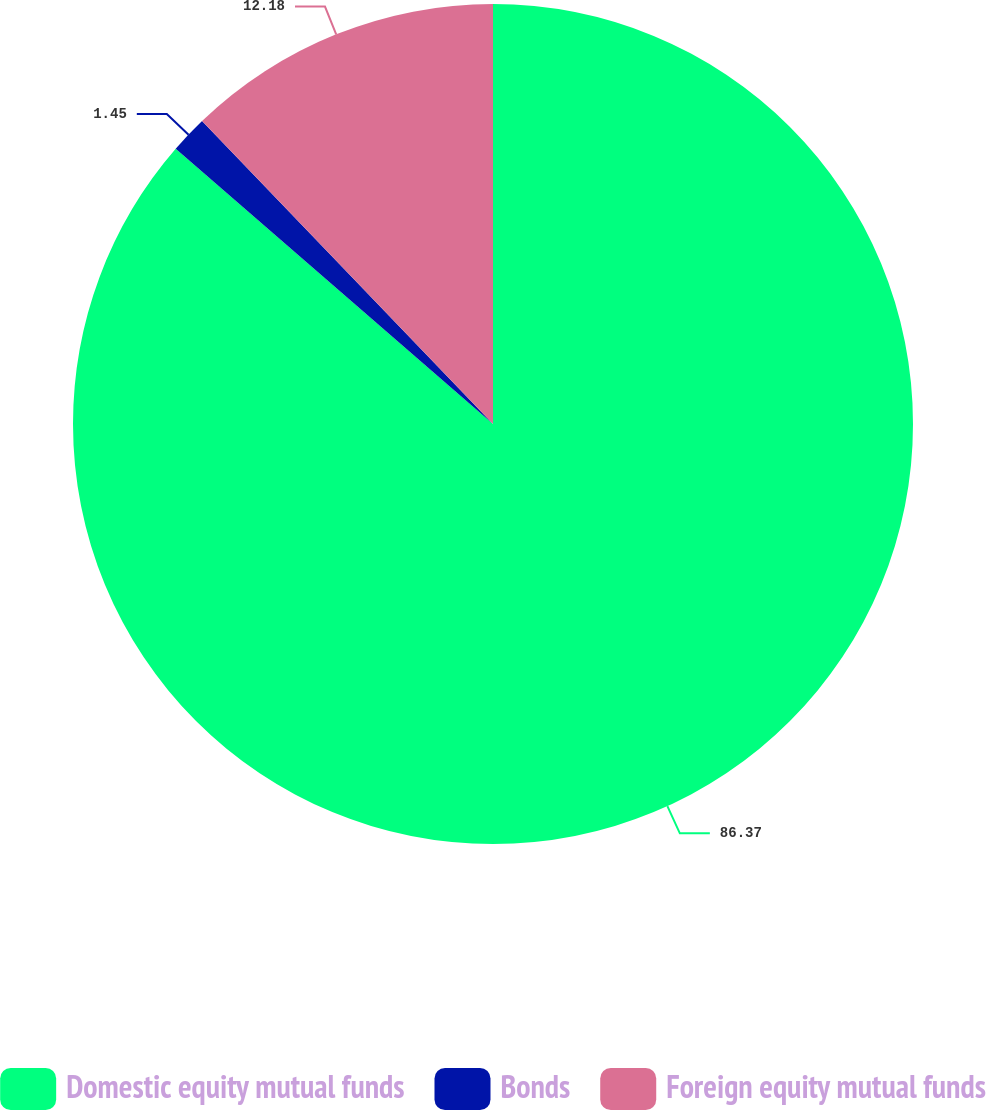Convert chart. <chart><loc_0><loc_0><loc_500><loc_500><pie_chart><fcel>Domestic equity mutual funds<fcel>Bonds<fcel>Foreign equity mutual funds<nl><fcel>86.37%<fcel>1.45%<fcel>12.18%<nl></chart> 